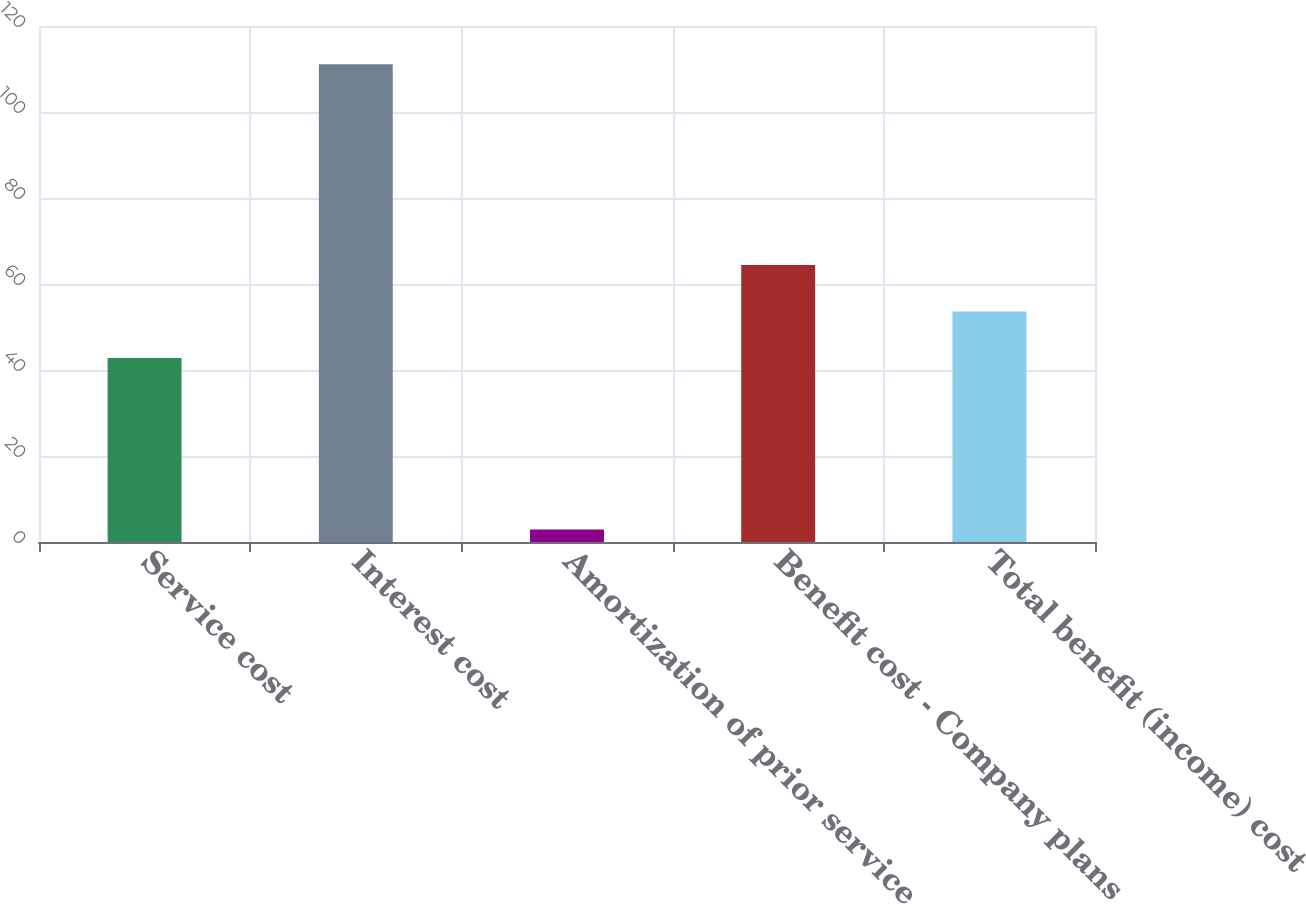Convert chart. <chart><loc_0><loc_0><loc_500><loc_500><bar_chart><fcel>Service cost<fcel>Interest cost<fcel>Amortization of prior service<fcel>Benefit cost - Company plans<fcel>Total benefit (income) cost<nl><fcel>42.8<fcel>111.1<fcel>2.9<fcel>64.44<fcel>53.62<nl></chart> 